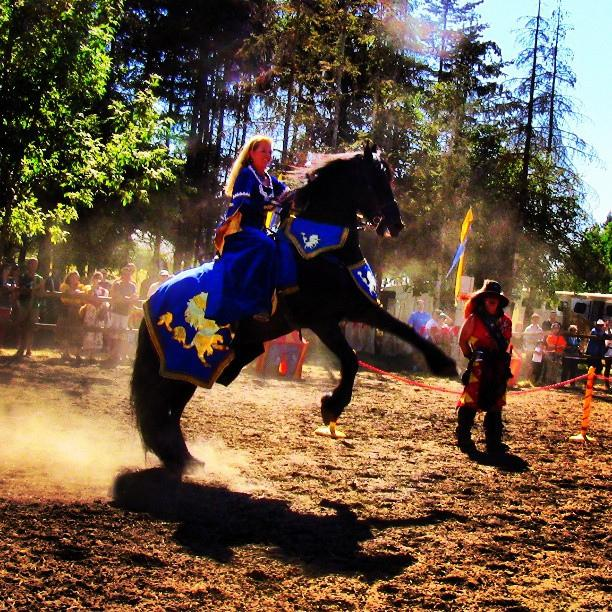What attire is the person standing behind the horse in front of the red rope wearing? clown 